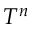<formula> <loc_0><loc_0><loc_500><loc_500>T ^ { n }</formula> 